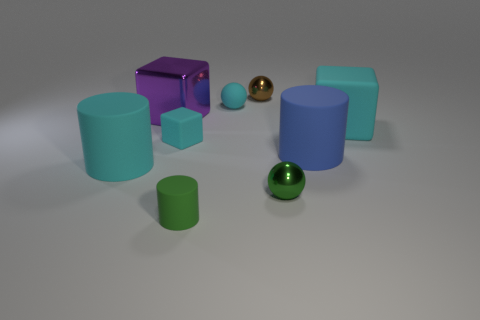What number of cyan things are tiny matte balls or small rubber cubes?
Give a very brief answer. 2. What is the shape of the big cyan matte object on the right side of the tiny green thing behind the green rubber object?
Give a very brief answer. Cube. The blue rubber object that is the same size as the cyan cylinder is what shape?
Provide a succinct answer. Cylinder. Is there a tiny rubber object that has the same color as the small block?
Make the answer very short. Yes. Is the number of small green things to the left of the rubber ball the same as the number of small brown spheres that are behind the purple object?
Give a very brief answer. Yes. There is a blue thing; does it have the same shape as the green thing that is to the left of the tiny brown shiny sphere?
Your answer should be compact. Yes. How many other things are there of the same material as the tiny cylinder?
Give a very brief answer. 5. There is a large purple metallic block; are there any large cyan things to the right of it?
Offer a very short reply. Yes. There is a green metal object; does it have the same size as the cyan sphere that is behind the tiny matte block?
Your answer should be compact. Yes. There is a big matte cylinder that is to the left of the blue thing that is in front of the small cyan block; what color is it?
Your answer should be very brief. Cyan. 